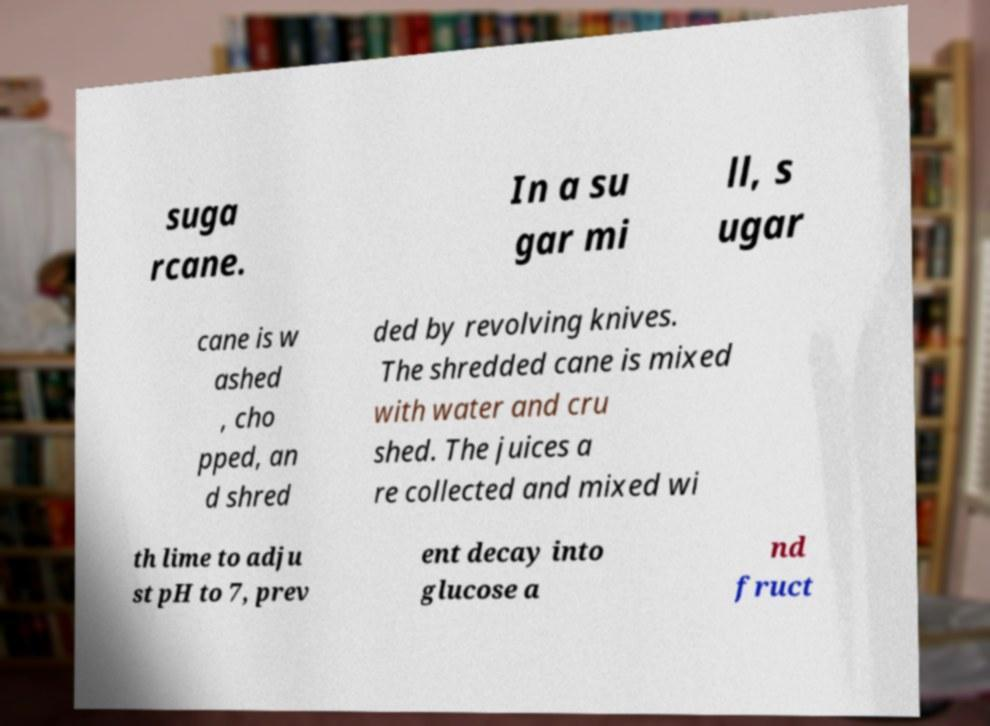There's text embedded in this image that I need extracted. Can you transcribe it verbatim? suga rcane. In a su gar mi ll, s ugar cane is w ashed , cho pped, an d shred ded by revolving knives. The shredded cane is mixed with water and cru shed. The juices a re collected and mixed wi th lime to adju st pH to 7, prev ent decay into glucose a nd fruct 